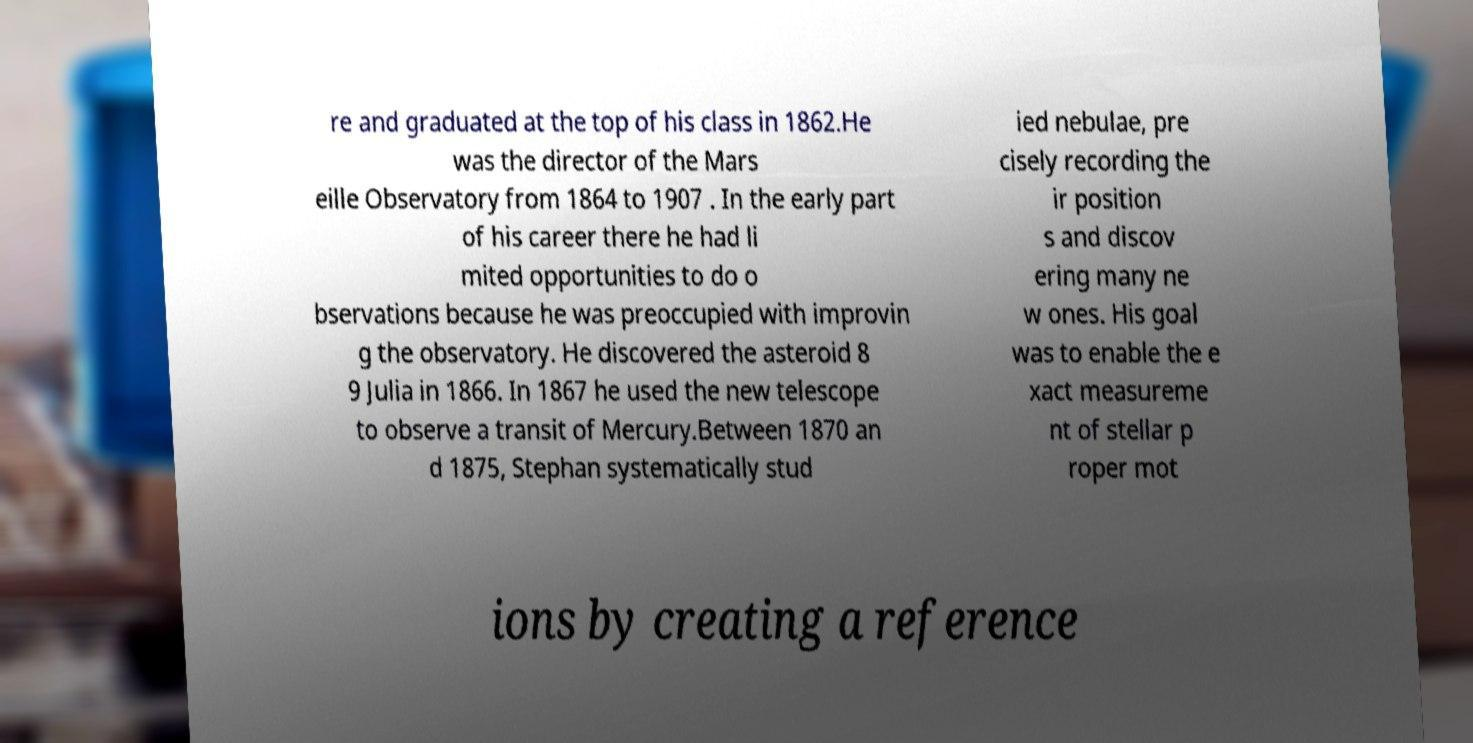Could you extract and type out the text from this image? re and graduated at the top of his class in 1862.He was the director of the Mars eille Observatory from 1864 to 1907 . In the early part of his career there he had li mited opportunities to do o bservations because he was preoccupied with improvin g the observatory. He discovered the asteroid 8 9 Julia in 1866. In 1867 he used the new telescope to observe a transit of Mercury.Between 1870 an d 1875, Stephan systematically stud ied nebulae, pre cisely recording the ir position s and discov ering many ne w ones. His goal was to enable the e xact measureme nt of stellar p roper mot ions by creating a reference 